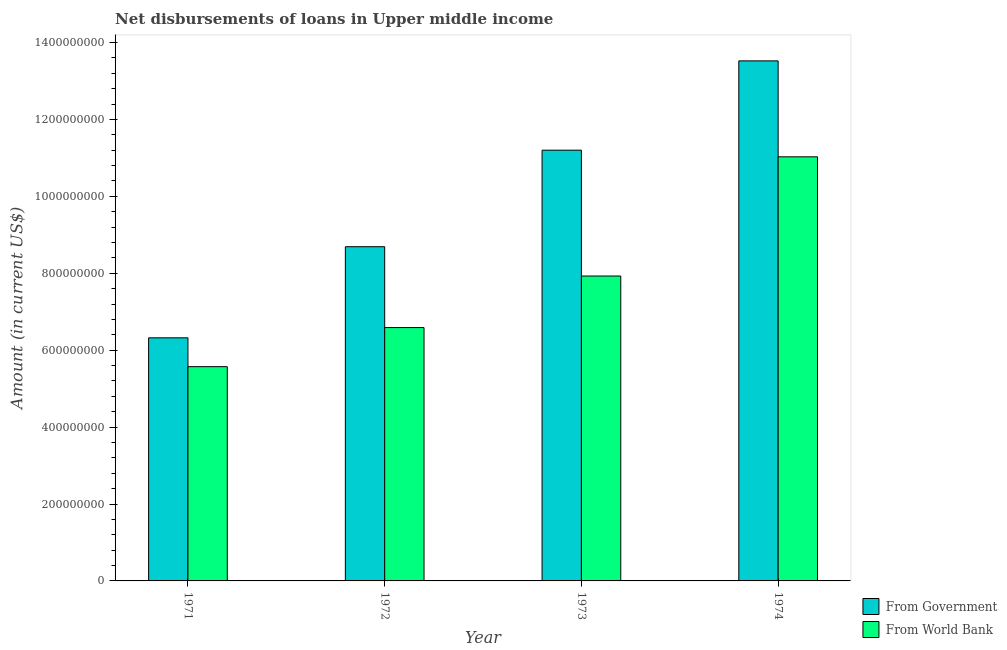How many groups of bars are there?
Your answer should be very brief. 4. Are the number of bars on each tick of the X-axis equal?
Your answer should be compact. Yes. How many bars are there on the 1st tick from the right?
Your answer should be compact. 2. What is the label of the 1st group of bars from the left?
Provide a short and direct response. 1971. In how many cases, is the number of bars for a given year not equal to the number of legend labels?
Provide a succinct answer. 0. What is the net disbursements of loan from government in 1972?
Your answer should be compact. 8.69e+08. Across all years, what is the maximum net disbursements of loan from government?
Your answer should be compact. 1.35e+09. Across all years, what is the minimum net disbursements of loan from world bank?
Keep it short and to the point. 5.57e+08. In which year was the net disbursements of loan from world bank maximum?
Ensure brevity in your answer.  1974. In which year was the net disbursements of loan from government minimum?
Ensure brevity in your answer.  1971. What is the total net disbursements of loan from world bank in the graph?
Make the answer very short. 3.11e+09. What is the difference between the net disbursements of loan from world bank in 1972 and that in 1974?
Keep it short and to the point. -4.44e+08. What is the difference between the net disbursements of loan from government in 1972 and the net disbursements of loan from world bank in 1974?
Offer a very short reply. -4.83e+08. What is the average net disbursements of loan from government per year?
Give a very brief answer. 9.93e+08. In the year 1971, what is the difference between the net disbursements of loan from world bank and net disbursements of loan from government?
Ensure brevity in your answer.  0. In how many years, is the net disbursements of loan from government greater than 1200000000 US$?
Give a very brief answer. 1. What is the ratio of the net disbursements of loan from world bank in 1973 to that in 1974?
Your response must be concise. 0.72. Is the difference between the net disbursements of loan from government in 1971 and 1972 greater than the difference between the net disbursements of loan from world bank in 1971 and 1972?
Offer a terse response. No. What is the difference between the highest and the second highest net disbursements of loan from world bank?
Give a very brief answer. 3.10e+08. What is the difference between the highest and the lowest net disbursements of loan from world bank?
Your answer should be compact. 5.46e+08. Is the sum of the net disbursements of loan from world bank in 1973 and 1974 greater than the maximum net disbursements of loan from government across all years?
Provide a succinct answer. Yes. What does the 2nd bar from the left in 1971 represents?
Make the answer very short. From World Bank. What does the 2nd bar from the right in 1973 represents?
Keep it short and to the point. From Government. How many bars are there?
Make the answer very short. 8. Where does the legend appear in the graph?
Keep it short and to the point. Bottom right. How many legend labels are there?
Your answer should be compact. 2. How are the legend labels stacked?
Ensure brevity in your answer.  Vertical. What is the title of the graph?
Provide a succinct answer. Net disbursements of loans in Upper middle income. Does "Unregistered firms" appear as one of the legend labels in the graph?
Offer a very short reply. No. What is the label or title of the X-axis?
Make the answer very short. Year. What is the label or title of the Y-axis?
Your response must be concise. Amount (in current US$). What is the Amount (in current US$) in From Government in 1971?
Your answer should be very brief. 6.32e+08. What is the Amount (in current US$) in From World Bank in 1971?
Offer a very short reply. 5.57e+08. What is the Amount (in current US$) of From Government in 1972?
Offer a very short reply. 8.69e+08. What is the Amount (in current US$) in From World Bank in 1972?
Provide a succinct answer. 6.59e+08. What is the Amount (in current US$) in From Government in 1973?
Provide a short and direct response. 1.12e+09. What is the Amount (in current US$) of From World Bank in 1973?
Provide a short and direct response. 7.93e+08. What is the Amount (in current US$) of From Government in 1974?
Provide a succinct answer. 1.35e+09. What is the Amount (in current US$) in From World Bank in 1974?
Your answer should be very brief. 1.10e+09. Across all years, what is the maximum Amount (in current US$) in From Government?
Offer a very short reply. 1.35e+09. Across all years, what is the maximum Amount (in current US$) in From World Bank?
Keep it short and to the point. 1.10e+09. Across all years, what is the minimum Amount (in current US$) of From Government?
Your response must be concise. 6.32e+08. Across all years, what is the minimum Amount (in current US$) of From World Bank?
Your answer should be compact. 5.57e+08. What is the total Amount (in current US$) of From Government in the graph?
Ensure brevity in your answer.  3.97e+09. What is the total Amount (in current US$) of From World Bank in the graph?
Offer a terse response. 3.11e+09. What is the difference between the Amount (in current US$) in From Government in 1971 and that in 1972?
Provide a succinct answer. -2.37e+08. What is the difference between the Amount (in current US$) of From World Bank in 1971 and that in 1972?
Your answer should be very brief. -1.02e+08. What is the difference between the Amount (in current US$) in From Government in 1971 and that in 1973?
Make the answer very short. -4.88e+08. What is the difference between the Amount (in current US$) of From World Bank in 1971 and that in 1973?
Your answer should be very brief. -2.36e+08. What is the difference between the Amount (in current US$) of From Government in 1971 and that in 1974?
Your response must be concise. -7.20e+08. What is the difference between the Amount (in current US$) in From World Bank in 1971 and that in 1974?
Make the answer very short. -5.46e+08. What is the difference between the Amount (in current US$) of From Government in 1972 and that in 1973?
Your answer should be compact. -2.51e+08. What is the difference between the Amount (in current US$) in From World Bank in 1972 and that in 1973?
Offer a terse response. -1.34e+08. What is the difference between the Amount (in current US$) of From Government in 1972 and that in 1974?
Keep it short and to the point. -4.83e+08. What is the difference between the Amount (in current US$) of From World Bank in 1972 and that in 1974?
Make the answer very short. -4.44e+08. What is the difference between the Amount (in current US$) in From Government in 1973 and that in 1974?
Your answer should be compact. -2.32e+08. What is the difference between the Amount (in current US$) in From World Bank in 1973 and that in 1974?
Your answer should be compact. -3.10e+08. What is the difference between the Amount (in current US$) of From Government in 1971 and the Amount (in current US$) of From World Bank in 1972?
Provide a succinct answer. -2.66e+07. What is the difference between the Amount (in current US$) in From Government in 1971 and the Amount (in current US$) in From World Bank in 1973?
Ensure brevity in your answer.  -1.61e+08. What is the difference between the Amount (in current US$) of From Government in 1971 and the Amount (in current US$) of From World Bank in 1974?
Offer a very short reply. -4.71e+08. What is the difference between the Amount (in current US$) in From Government in 1972 and the Amount (in current US$) in From World Bank in 1973?
Your answer should be compact. 7.62e+07. What is the difference between the Amount (in current US$) of From Government in 1972 and the Amount (in current US$) of From World Bank in 1974?
Keep it short and to the point. -2.34e+08. What is the difference between the Amount (in current US$) of From Government in 1973 and the Amount (in current US$) of From World Bank in 1974?
Give a very brief answer. 1.73e+07. What is the average Amount (in current US$) in From Government per year?
Offer a very short reply. 9.93e+08. What is the average Amount (in current US$) of From World Bank per year?
Your answer should be compact. 7.78e+08. In the year 1971, what is the difference between the Amount (in current US$) of From Government and Amount (in current US$) of From World Bank?
Offer a terse response. 7.50e+07. In the year 1972, what is the difference between the Amount (in current US$) in From Government and Amount (in current US$) in From World Bank?
Offer a terse response. 2.10e+08. In the year 1973, what is the difference between the Amount (in current US$) of From Government and Amount (in current US$) of From World Bank?
Keep it short and to the point. 3.27e+08. In the year 1974, what is the difference between the Amount (in current US$) of From Government and Amount (in current US$) of From World Bank?
Offer a very short reply. 2.49e+08. What is the ratio of the Amount (in current US$) in From Government in 1971 to that in 1972?
Ensure brevity in your answer.  0.73. What is the ratio of the Amount (in current US$) in From World Bank in 1971 to that in 1972?
Offer a terse response. 0.85. What is the ratio of the Amount (in current US$) in From Government in 1971 to that in 1973?
Ensure brevity in your answer.  0.56. What is the ratio of the Amount (in current US$) in From World Bank in 1971 to that in 1973?
Give a very brief answer. 0.7. What is the ratio of the Amount (in current US$) of From Government in 1971 to that in 1974?
Provide a short and direct response. 0.47. What is the ratio of the Amount (in current US$) of From World Bank in 1971 to that in 1974?
Give a very brief answer. 0.51. What is the ratio of the Amount (in current US$) of From Government in 1972 to that in 1973?
Offer a very short reply. 0.78. What is the ratio of the Amount (in current US$) of From World Bank in 1972 to that in 1973?
Your answer should be compact. 0.83. What is the ratio of the Amount (in current US$) of From Government in 1972 to that in 1974?
Your response must be concise. 0.64. What is the ratio of the Amount (in current US$) of From World Bank in 1972 to that in 1974?
Provide a succinct answer. 0.6. What is the ratio of the Amount (in current US$) in From Government in 1973 to that in 1974?
Ensure brevity in your answer.  0.83. What is the ratio of the Amount (in current US$) of From World Bank in 1973 to that in 1974?
Your answer should be compact. 0.72. What is the difference between the highest and the second highest Amount (in current US$) in From Government?
Give a very brief answer. 2.32e+08. What is the difference between the highest and the second highest Amount (in current US$) of From World Bank?
Keep it short and to the point. 3.10e+08. What is the difference between the highest and the lowest Amount (in current US$) of From Government?
Your answer should be compact. 7.20e+08. What is the difference between the highest and the lowest Amount (in current US$) in From World Bank?
Make the answer very short. 5.46e+08. 